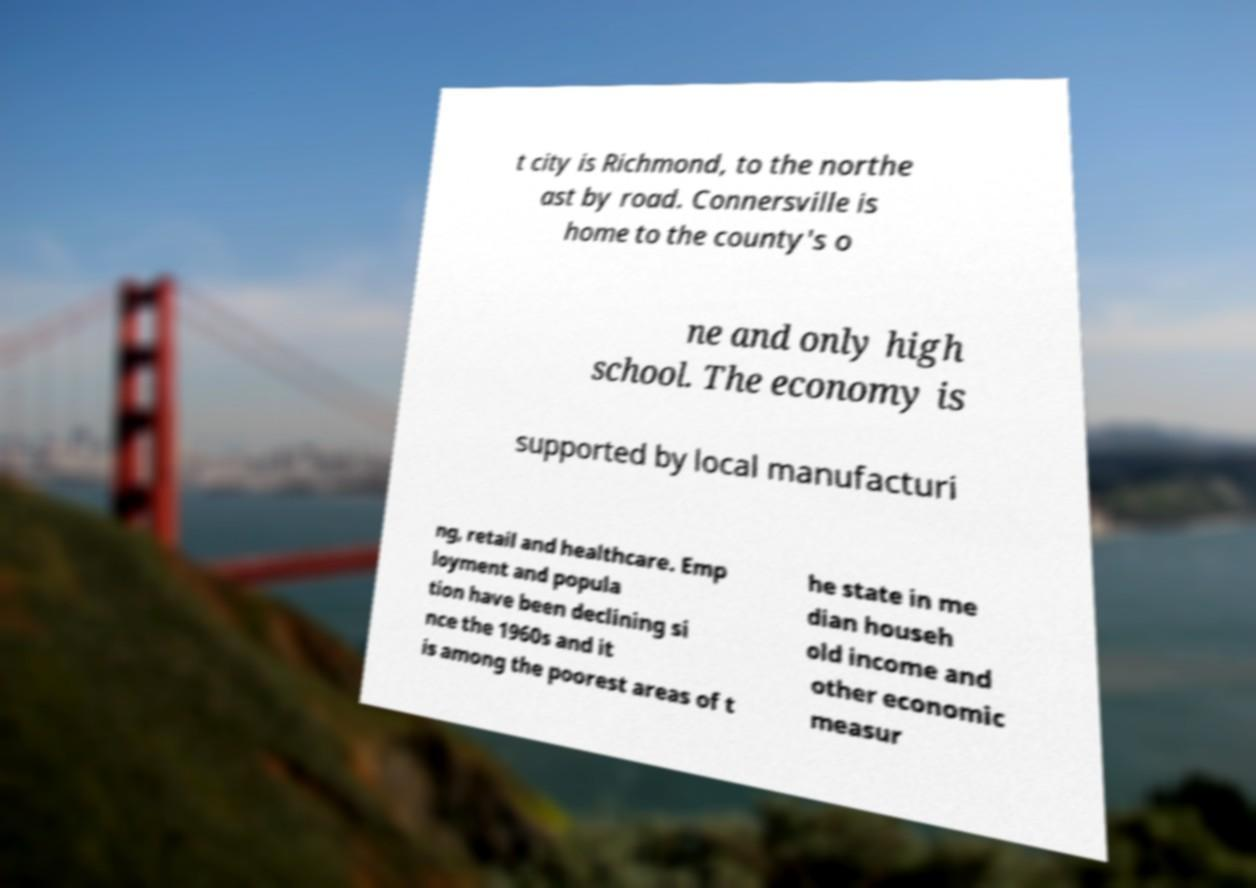Can you accurately transcribe the text from the provided image for me? t city is Richmond, to the northe ast by road. Connersville is home to the county's o ne and only high school. The economy is supported by local manufacturi ng, retail and healthcare. Emp loyment and popula tion have been declining si nce the 1960s and it is among the poorest areas of t he state in me dian househ old income and other economic measur 